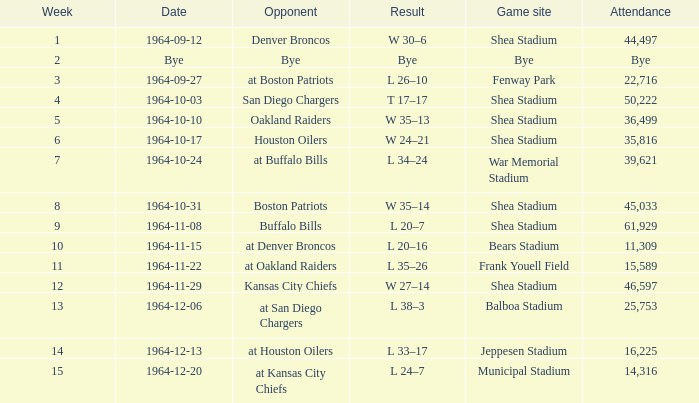What's the conclusion for week 15? L 24–7. 